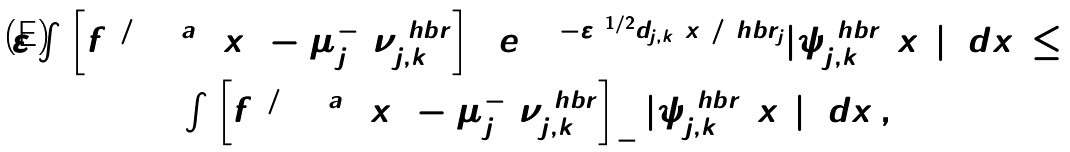<formula> <loc_0><loc_0><loc_500><loc_500>\begin{array} { c } \varepsilon \int \left [ f ^ { 2 / ( 2 + a ) } ( x ) - \mu _ { j } ^ { - 1 } \nu _ { j , k } ^ { \ h b r } \right ] _ { + } e ^ { 2 ( 1 - \varepsilon ) ^ { 1 / 2 } d _ { j , k } ( x ) / \ h b r _ { j } } | \psi _ { j , k } ^ { \ h b r } ( x ) | ^ { 2 } \, d x \, \leq \\ \int \left [ f ^ { 2 / ( 2 + a ) } ( x ) - \mu _ { j } ^ { - 1 } \nu _ { j , k } ^ { \ h b r } \right ] _ { - } | \psi _ { j , k } ^ { \ h b r } ( x ) | ^ { 2 } \, d x \, , \end{array}</formula> 